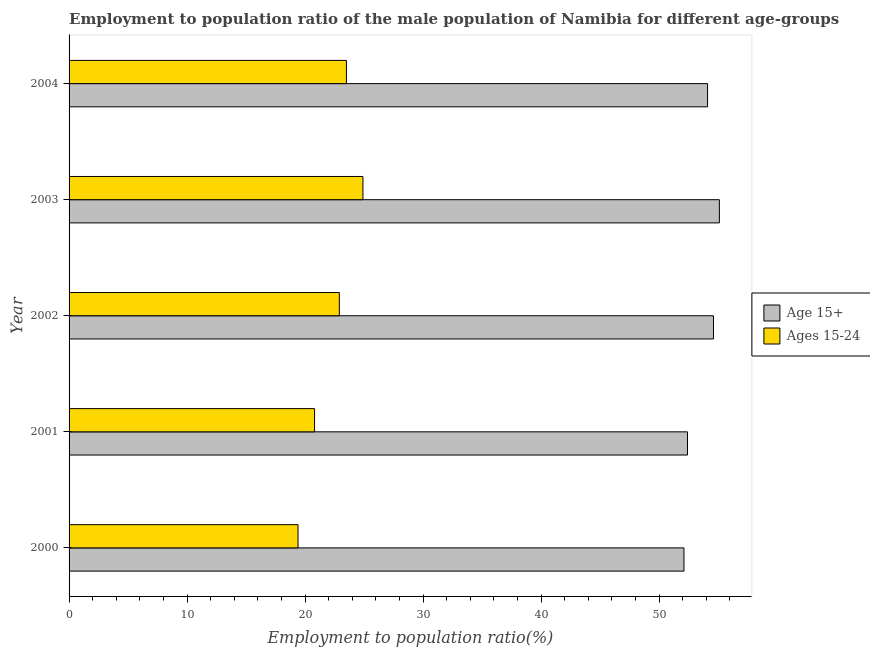Are the number of bars per tick equal to the number of legend labels?
Your response must be concise. Yes. Are the number of bars on each tick of the Y-axis equal?
Give a very brief answer. Yes. How many bars are there on the 1st tick from the top?
Make the answer very short. 2. What is the label of the 3rd group of bars from the top?
Offer a terse response. 2002. Across all years, what is the maximum employment to population ratio(age 15+)?
Your answer should be very brief. 55.1. Across all years, what is the minimum employment to population ratio(age 15-24)?
Offer a very short reply. 19.4. In which year was the employment to population ratio(age 15+) maximum?
Provide a succinct answer. 2003. What is the total employment to population ratio(age 15-24) in the graph?
Keep it short and to the point. 111.5. What is the difference between the employment to population ratio(age 15-24) in 2002 and the employment to population ratio(age 15+) in 2004?
Make the answer very short. -31.2. What is the average employment to population ratio(age 15+) per year?
Ensure brevity in your answer.  53.66. In the year 2002, what is the difference between the employment to population ratio(age 15-24) and employment to population ratio(age 15+)?
Your answer should be very brief. -31.7. What is the ratio of the employment to population ratio(age 15-24) in 2000 to that in 2002?
Give a very brief answer. 0.85. Is the employment to population ratio(age 15+) in 2000 less than that in 2004?
Provide a short and direct response. Yes. Is the difference between the employment to population ratio(age 15-24) in 2001 and 2002 greater than the difference between the employment to population ratio(age 15+) in 2001 and 2002?
Make the answer very short. Yes. What is the difference between the highest and the lowest employment to population ratio(age 15+)?
Provide a succinct answer. 3. What does the 1st bar from the top in 2003 represents?
Give a very brief answer. Ages 15-24. What does the 1st bar from the bottom in 2000 represents?
Offer a terse response. Age 15+. Are all the bars in the graph horizontal?
Ensure brevity in your answer.  Yes. How many years are there in the graph?
Make the answer very short. 5. Are the values on the major ticks of X-axis written in scientific E-notation?
Your answer should be very brief. No. Does the graph contain any zero values?
Offer a terse response. No. Where does the legend appear in the graph?
Your answer should be very brief. Center right. How many legend labels are there?
Give a very brief answer. 2. What is the title of the graph?
Provide a succinct answer. Employment to population ratio of the male population of Namibia for different age-groups. What is the label or title of the X-axis?
Ensure brevity in your answer.  Employment to population ratio(%). What is the Employment to population ratio(%) of Age 15+ in 2000?
Your response must be concise. 52.1. What is the Employment to population ratio(%) of Ages 15-24 in 2000?
Ensure brevity in your answer.  19.4. What is the Employment to population ratio(%) in Age 15+ in 2001?
Provide a succinct answer. 52.4. What is the Employment to population ratio(%) in Ages 15-24 in 2001?
Give a very brief answer. 20.8. What is the Employment to population ratio(%) of Age 15+ in 2002?
Offer a terse response. 54.6. What is the Employment to population ratio(%) in Ages 15-24 in 2002?
Provide a short and direct response. 22.9. What is the Employment to population ratio(%) of Age 15+ in 2003?
Provide a succinct answer. 55.1. What is the Employment to population ratio(%) in Ages 15-24 in 2003?
Keep it short and to the point. 24.9. What is the Employment to population ratio(%) of Age 15+ in 2004?
Keep it short and to the point. 54.1. Across all years, what is the maximum Employment to population ratio(%) of Age 15+?
Your answer should be very brief. 55.1. Across all years, what is the maximum Employment to population ratio(%) of Ages 15-24?
Your response must be concise. 24.9. Across all years, what is the minimum Employment to population ratio(%) of Age 15+?
Give a very brief answer. 52.1. Across all years, what is the minimum Employment to population ratio(%) of Ages 15-24?
Provide a short and direct response. 19.4. What is the total Employment to population ratio(%) in Age 15+ in the graph?
Provide a succinct answer. 268.3. What is the total Employment to population ratio(%) of Ages 15-24 in the graph?
Your answer should be compact. 111.5. What is the difference between the Employment to population ratio(%) of Ages 15-24 in 2000 and that in 2001?
Keep it short and to the point. -1.4. What is the difference between the Employment to population ratio(%) of Age 15+ in 2000 and that in 2002?
Your answer should be very brief. -2.5. What is the difference between the Employment to population ratio(%) in Age 15+ in 2000 and that in 2003?
Your answer should be very brief. -3. What is the difference between the Employment to population ratio(%) of Ages 15-24 in 2000 and that in 2004?
Your answer should be compact. -4.1. What is the difference between the Employment to population ratio(%) of Age 15+ in 2001 and that in 2003?
Ensure brevity in your answer.  -2.7. What is the difference between the Employment to population ratio(%) of Ages 15-24 in 2001 and that in 2003?
Give a very brief answer. -4.1. What is the difference between the Employment to population ratio(%) in Age 15+ in 2002 and that in 2003?
Provide a short and direct response. -0.5. What is the difference between the Employment to population ratio(%) in Ages 15-24 in 2002 and that in 2003?
Give a very brief answer. -2. What is the difference between the Employment to population ratio(%) in Age 15+ in 2002 and that in 2004?
Provide a short and direct response. 0.5. What is the difference between the Employment to population ratio(%) of Age 15+ in 2003 and that in 2004?
Provide a short and direct response. 1. What is the difference between the Employment to population ratio(%) in Age 15+ in 2000 and the Employment to population ratio(%) in Ages 15-24 in 2001?
Your response must be concise. 31.3. What is the difference between the Employment to population ratio(%) of Age 15+ in 2000 and the Employment to population ratio(%) of Ages 15-24 in 2002?
Give a very brief answer. 29.2. What is the difference between the Employment to population ratio(%) in Age 15+ in 2000 and the Employment to population ratio(%) in Ages 15-24 in 2003?
Offer a very short reply. 27.2. What is the difference between the Employment to population ratio(%) in Age 15+ in 2000 and the Employment to population ratio(%) in Ages 15-24 in 2004?
Your answer should be compact. 28.6. What is the difference between the Employment to population ratio(%) in Age 15+ in 2001 and the Employment to population ratio(%) in Ages 15-24 in 2002?
Give a very brief answer. 29.5. What is the difference between the Employment to population ratio(%) in Age 15+ in 2001 and the Employment to population ratio(%) in Ages 15-24 in 2004?
Make the answer very short. 28.9. What is the difference between the Employment to population ratio(%) in Age 15+ in 2002 and the Employment to population ratio(%) in Ages 15-24 in 2003?
Offer a very short reply. 29.7. What is the difference between the Employment to population ratio(%) in Age 15+ in 2002 and the Employment to population ratio(%) in Ages 15-24 in 2004?
Offer a very short reply. 31.1. What is the difference between the Employment to population ratio(%) of Age 15+ in 2003 and the Employment to population ratio(%) of Ages 15-24 in 2004?
Offer a terse response. 31.6. What is the average Employment to population ratio(%) of Age 15+ per year?
Offer a very short reply. 53.66. What is the average Employment to population ratio(%) of Ages 15-24 per year?
Your answer should be compact. 22.3. In the year 2000, what is the difference between the Employment to population ratio(%) in Age 15+ and Employment to population ratio(%) in Ages 15-24?
Your answer should be compact. 32.7. In the year 2001, what is the difference between the Employment to population ratio(%) in Age 15+ and Employment to population ratio(%) in Ages 15-24?
Make the answer very short. 31.6. In the year 2002, what is the difference between the Employment to population ratio(%) of Age 15+ and Employment to population ratio(%) of Ages 15-24?
Make the answer very short. 31.7. In the year 2003, what is the difference between the Employment to population ratio(%) in Age 15+ and Employment to population ratio(%) in Ages 15-24?
Your response must be concise. 30.2. In the year 2004, what is the difference between the Employment to population ratio(%) in Age 15+ and Employment to population ratio(%) in Ages 15-24?
Your answer should be compact. 30.6. What is the ratio of the Employment to population ratio(%) in Ages 15-24 in 2000 to that in 2001?
Ensure brevity in your answer.  0.93. What is the ratio of the Employment to population ratio(%) of Age 15+ in 2000 to that in 2002?
Your response must be concise. 0.95. What is the ratio of the Employment to population ratio(%) in Ages 15-24 in 2000 to that in 2002?
Ensure brevity in your answer.  0.85. What is the ratio of the Employment to population ratio(%) of Age 15+ in 2000 to that in 2003?
Ensure brevity in your answer.  0.95. What is the ratio of the Employment to population ratio(%) of Ages 15-24 in 2000 to that in 2003?
Make the answer very short. 0.78. What is the ratio of the Employment to population ratio(%) in Ages 15-24 in 2000 to that in 2004?
Ensure brevity in your answer.  0.83. What is the ratio of the Employment to population ratio(%) of Age 15+ in 2001 to that in 2002?
Your answer should be compact. 0.96. What is the ratio of the Employment to population ratio(%) of Ages 15-24 in 2001 to that in 2002?
Give a very brief answer. 0.91. What is the ratio of the Employment to population ratio(%) of Age 15+ in 2001 to that in 2003?
Offer a terse response. 0.95. What is the ratio of the Employment to population ratio(%) in Ages 15-24 in 2001 to that in 2003?
Provide a short and direct response. 0.84. What is the ratio of the Employment to population ratio(%) of Age 15+ in 2001 to that in 2004?
Your answer should be very brief. 0.97. What is the ratio of the Employment to population ratio(%) of Ages 15-24 in 2001 to that in 2004?
Provide a short and direct response. 0.89. What is the ratio of the Employment to population ratio(%) in Age 15+ in 2002 to that in 2003?
Provide a short and direct response. 0.99. What is the ratio of the Employment to population ratio(%) of Ages 15-24 in 2002 to that in 2003?
Offer a terse response. 0.92. What is the ratio of the Employment to population ratio(%) in Age 15+ in 2002 to that in 2004?
Ensure brevity in your answer.  1.01. What is the ratio of the Employment to population ratio(%) of Ages 15-24 in 2002 to that in 2004?
Offer a terse response. 0.97. What is the ratio of the Employment to population ratio(%) in Age 15+ in 2003 to that in 2004?
Keep it short and to the point. 1.02. What is the ratio of the Employment to population ratio(%) of Ages 15-24 in 2003 to that in 2004?
Keep it short and to the point. 1.06. What is the difference between the highest and the second highest Employment to population ratio(%) in Age 15+?
Provide a short and direct response. 0.5. What is the difference between the highest and the second highest Employment to population ratio(%) of Ages 15-24?
Give a very brief answer. 1.4. What is the difference between the highest and the lowest Employment to population ratio(%) of Age 15+?
Ensure brevity in your answer.  3. What is the difference between the highest and the lowest Employment to population ratio(%) in Ages 15-24?
Offer a very short reply. 5.5. 